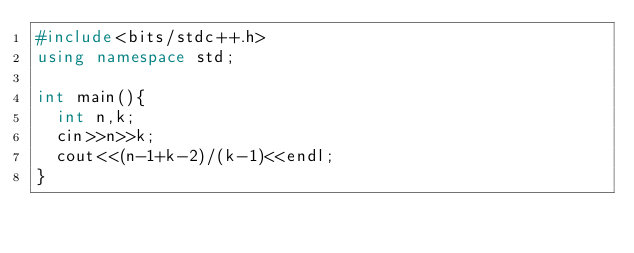Convert code to text. <code><loc_0><loc_0><loc_500><loc_500><_C++_>#include<bits/stdc++.h>
using namespace std;

int main(){
  int n,k;
  cin>>n>>k;
  cout<<(n-1+k-2)/(k-1)<<endl;
}</code> 